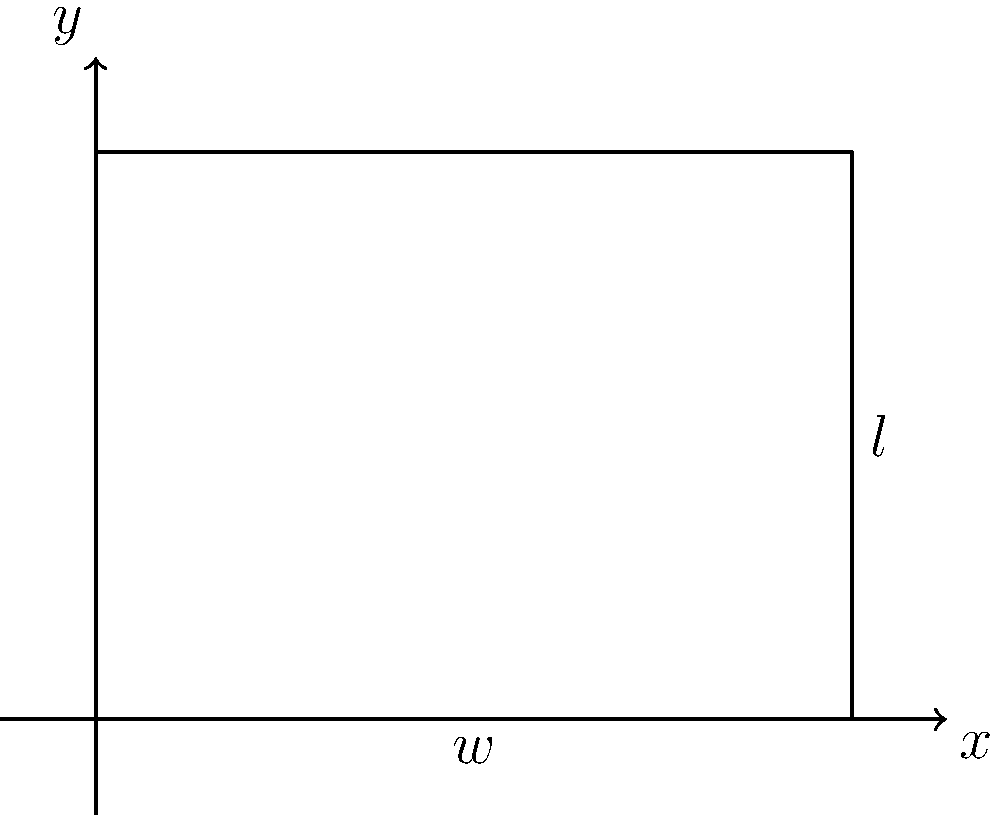Given a rectangle with a fixed perimeter of 20 units, write a function in a functional programming style to find the dimensions (length and width) that maximize the area of the rectangle. What are the optimal dimensions and the maximum area? Let's approach this step-by-step using functional programming concepts:

1) Let $w$ be the width and $l$ be the length of the rectangle.

2) Given the perimeter is 20, we can express this as:
   $2w + 2l = 20$ or $l = 10 - w$

3) The area of the rectangle is $A = w * l = w(10-w) = 10w - w^2$

4) To find the maximum, we need to find where the derivative of A with respect to w is zero:
   $\frac{dA}{dw} = 10 - 2w = 0$

5) Solving this, we get $w = 5$, and consequently, $l = 5$

6) We can verify this is a maximum by checking the second derivative is negative:
   $\frac{d^2A}{dw^2} = -2 < 0$

7) In functional programming, we could define a function to calculate the area:

   ```
   let area w = w * (10 - w)
   ```

8) To find the maximum, we could use a higher-order function like `maximumBy` in Haskell:

   ```
   let optimalWidth = maximumBy (comparing area) [0..10]
   let optimalLength = 10 - optimalWidth
   let maxArea = area optimalWidth
   ```

9) The optimal dimensions are 5x5, and the maximum area is 25 square units.
Answer: Width = 5, Length = 5, Maximum Area = 25 square units 